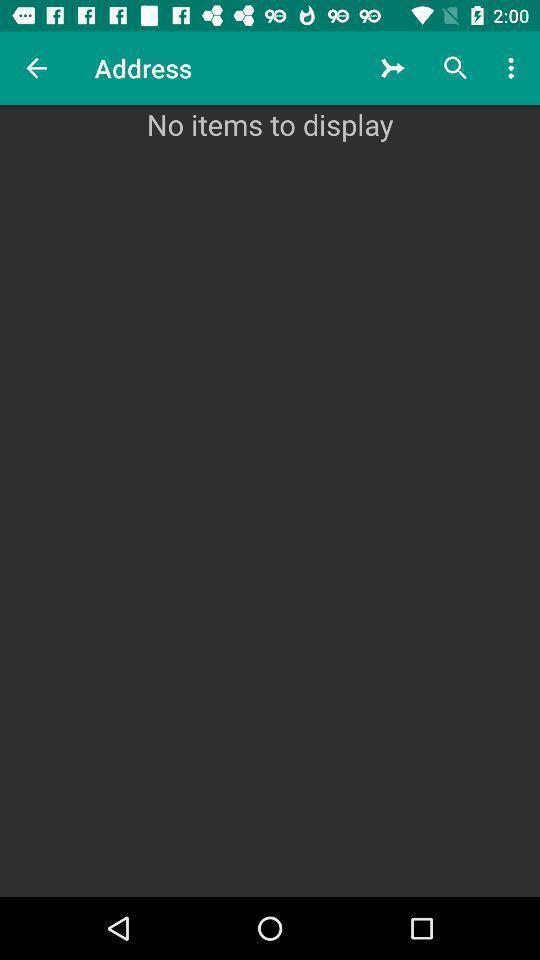Describe the key features of this screenshot. Screen display the empty list of address. 